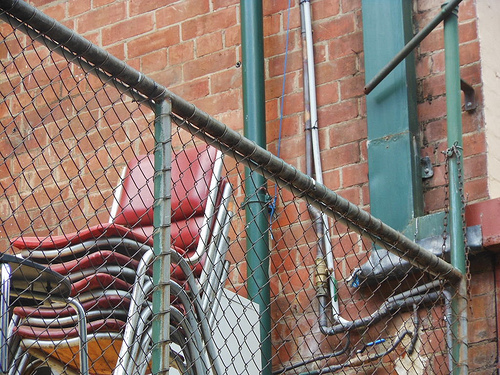<image>
Is there a chair in front of the fence? No. The chair is not in front of the fence. The spatial positioning shows a different relationship between these objects. 